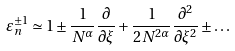Convert formula to latex. <formula><loc_0><loc_0><loc_500><loc_500>\varepsilon _ { n } ^ { \pm 1 } \simeq 1 \pm \frac { 1 } { N ^ { \alpha } } \frac { \partial } { \partial \xi } + \frac { 1 } { 2 N ^ { 2 \alpha } } \frac { \partial ^ { 2 } } { \partial \xi ^ { 2 } } \pm \dots</formula> 